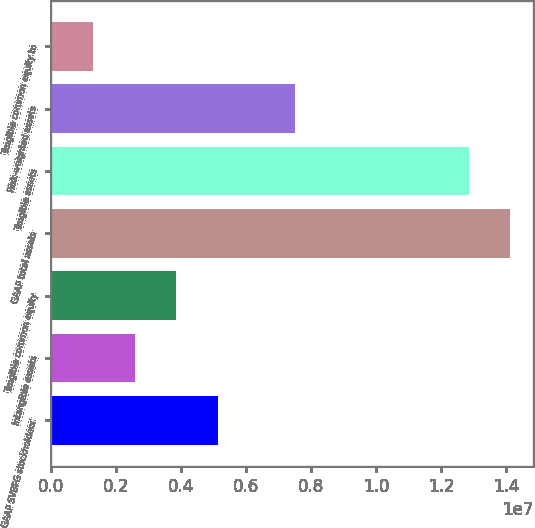<chart> <loc_0><loc_0><loc_500><loc_500><bar_chart><fcel>GAAP SVBFG stockholders'<fcel>Intangible assets<fcel>Tangible common equity<fcel>GAAP total assets<fcel>Tangible assets<fcel>Risk-weighted assets<fcel>Tangible common equity to<nl><fcel>5.13656e+06<fcel>2.56829e+06<fcel>3.85243e+06<fcel>1.41249e+07<fcel>1.28407e+07<fcel>7.4945e+06<fcel>1.28415e+06<nl></chart> 